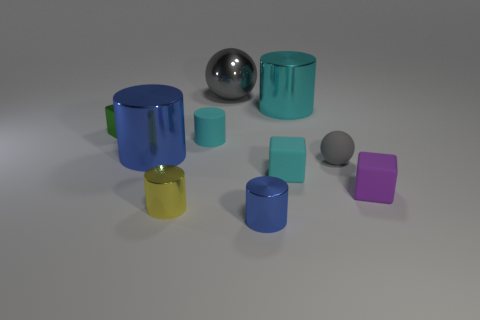There is an object that is behind the cyan cylinder that is behind the cube behind the small cyan matte cylinder; what color is it? The object in question, situated behind the cyan cylinder, which itself is positioned behind a cube and a small cyan matte cylinder, appears to be gray in color. It's a sphere with a metallic finish, reflecting its surroundings with a subtle luster. 